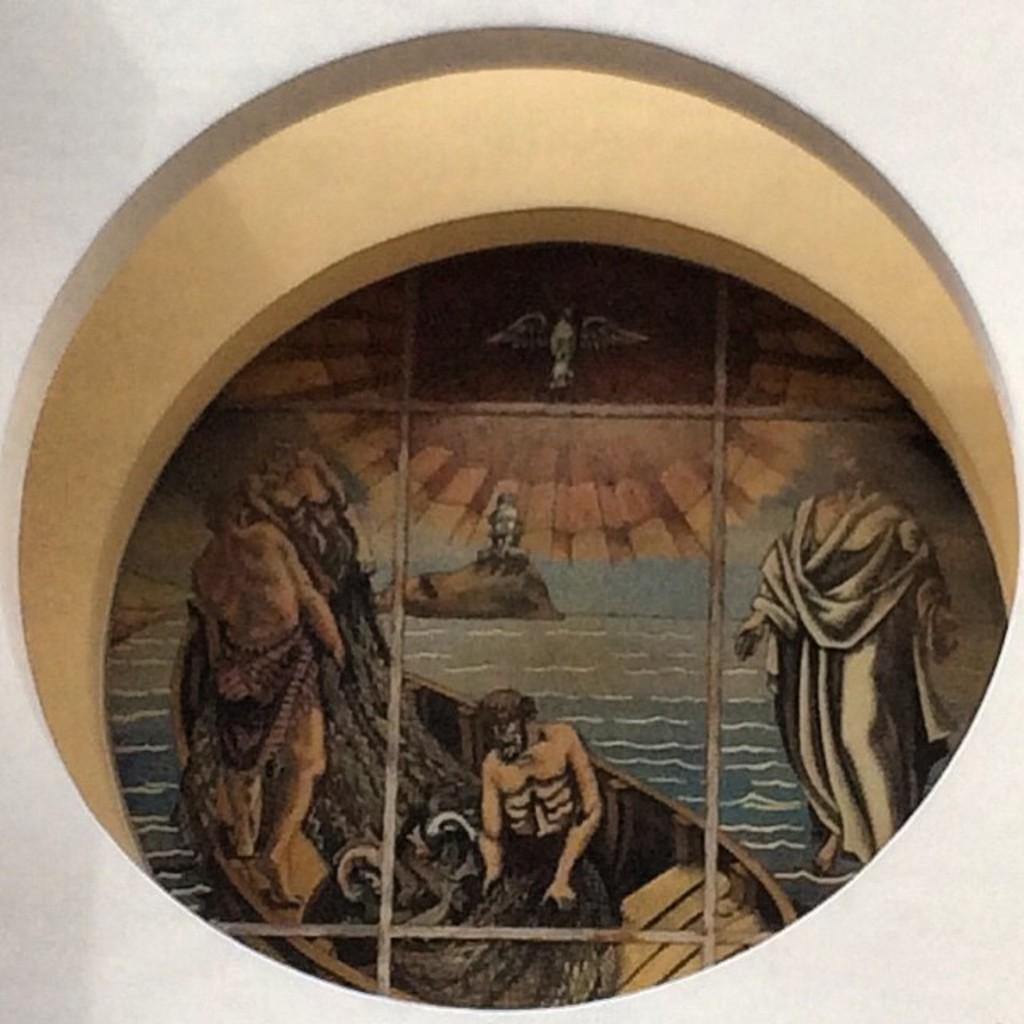How many persons are depicted in the painting? The painting contains a few persons. What type of natural formation can be seen in the painting? There is a rock in the painting. What type of animal is present in the painting? There is a bird in the painting. What mode of transportation is included in the painting? There is a boat in the painting. What architectural feature is present in the painting? There are iron grilles in the painting. What type of linen is being used to dry the bird in the painting? There is no linen or drying activity involving the bird in the painting. Why is the bird crying in the painting? Birds do not cry like humans, and there is no indication of any emotional state in the painting. 